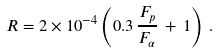<formula> <loc_0><loc_0><loc_500><loc_500>R = 2 \times 1 0 ^ { - 4 } \left ( 0 . 3 \, \frac { F _ { p } } { F _ { \alpha } } \, + \, 1 \right ) \, .</formula> 